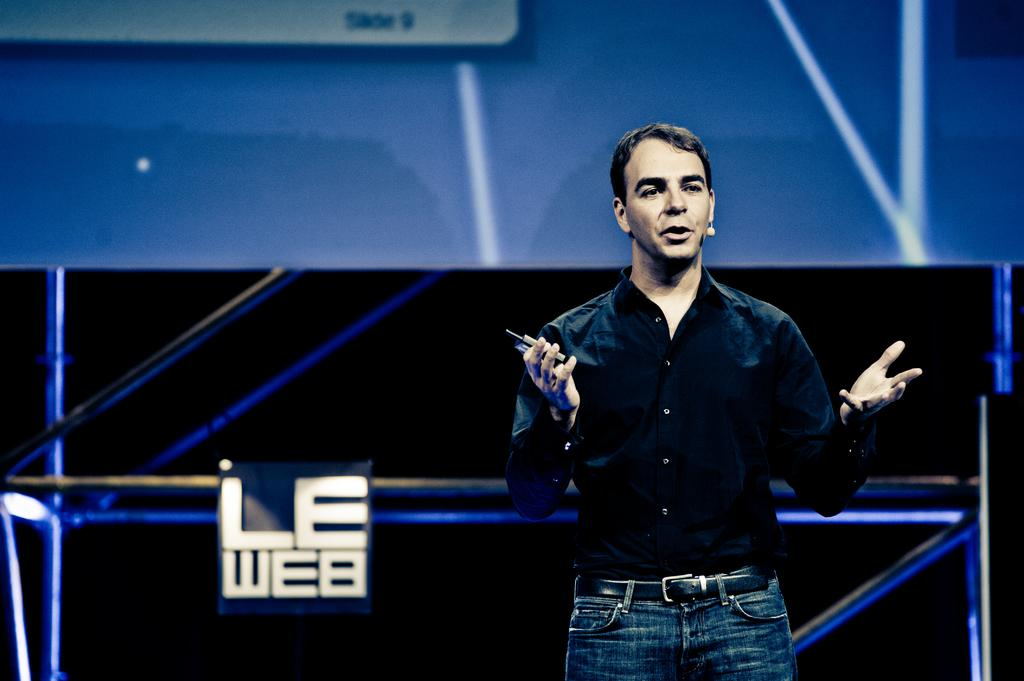Who is present in the image? There is a man in the image. What is the man doing in the image? The man is holding an object with his hand. What can be seen in the background of the image? There is a wall and objects in the background of the image. What is the man's annual income based on the image? The image does not provide any information about the man's income, so it cannot be determined from the image. 